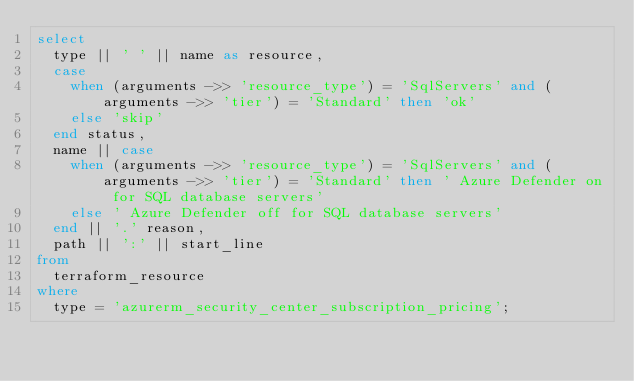Convert code to text. <code><loc_0><loc_0><loc_500><loc_500><_SQL_>select
  type || ' ' || name as resource,
  case
    when (arguments ->> 'resource_type') = 'SqlServers' and (arguments ->> 'tier') = 'Standard' then 'ok'
    else 'skip'
  end status,
  name || case
    when (arguments ->> 'resource_type') = 'SqlServers' and (arguments ->> 'tier') = 'Standard' then ' Azure Defender on for SQL database servers'
    else ' Azure Defender off for SQL database servers'
  end || '.' reason,
  path || ':' || start_line
from
  terraform_resource
where
  type = 'azurerm_security_center_subscription_pricing';</code> 